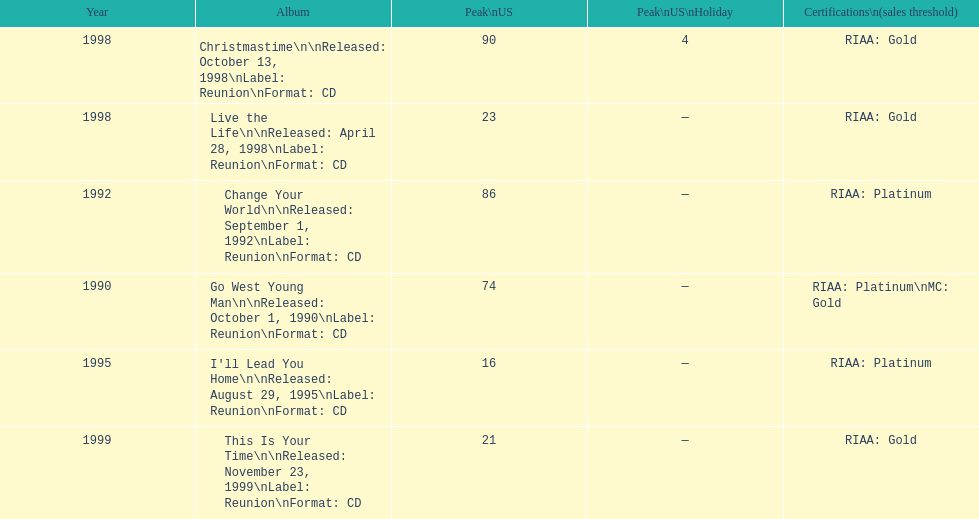What michael w smith album was released before his christmastime album? Live the Life. 